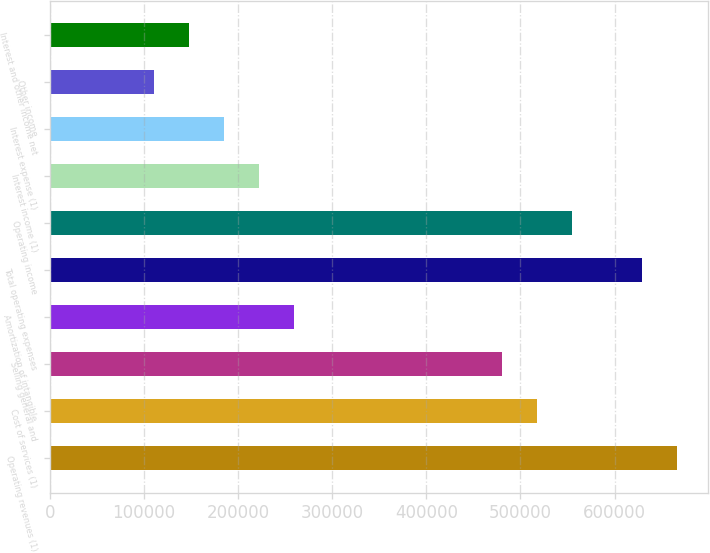<chart> <loc_0><loc_0><loc_500><loc_500><bar_chart><fcel>Operating revenues (1)<fcel>Cost of services (1)<fcel>Selling general and<fcel>Amortization of intangible<fcel>Total operating expenses<fcel>Operating income<fcel>Interest income (1)<fcel>Interest expense (1)<fcel>Other income<fcel>Interest and other income net<nl><fcel>665794<fcel>517840<fcel>480851<fcel>258920<fcel>628805<fcel>554828<fcel>221932<fcel>184943<fcel>110966<fcel>147955<nl></chart> 